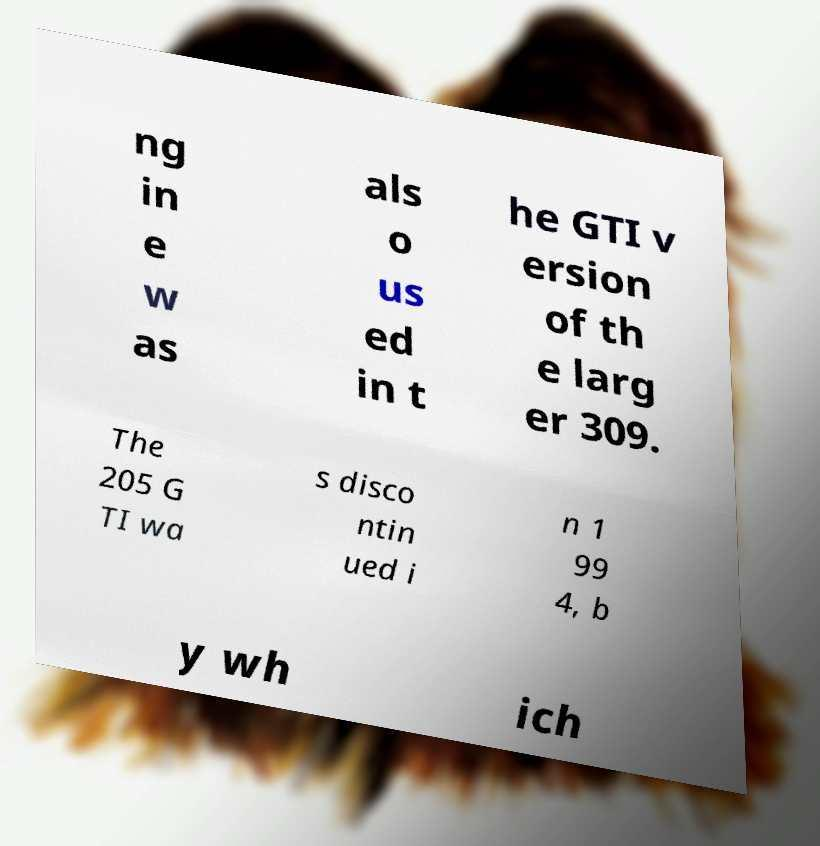Could you assist in decoding the text presented in this image and type it out clearly? ng in e w as als o us ed in t he GTI v ersion of th e larg er 309. The 205 G TI wa s disco ntin ued i n 1 99 4, b y wh ich 